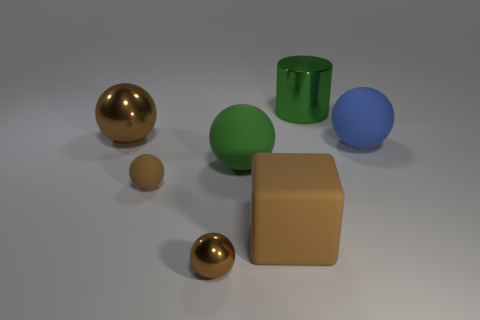What shape is the rubber thing that is the same color as the cylinder?
Your answer should be compact. Sphere. What number of metallic things are behind the metal sphere in front of the blue matte thing?
Your answer should be very brief. 2. How big is the object that is both behind the blue rubber sphere and on the right side of the big green rubber sphere?
Give a very brief answer. Large. Are there any matte blocks of the same size as the brown matte sphere?
Your answer should be compact. No. Is the number of brown matte cubes that are left of the green matte ball greater than the number of small spheres behind the large brown block?
Your answer should be compact. No. Do the big cube and the large brown object that is behind the large blue rubber ball have the same material?
Your answer should be compact. No. There is a big green thing behind the big object on the left side of the brown matte sphere; what number of rubber spheres are to the right of it?
Provide a short and direct response. 1. There is a large blue matte thing; does it have the same shape as the green thing that is in front of the green metal cylinder?
Ensure brevity in your answer.  Yes. The shiny object that is behind the brown rubber cube and right of the large brown ball is what color?
Ensure brevity in your answer.  Green. What is the large ball that is on the left side of the brown metal object that is in front of the brown metal thing behind the blue rubber ball made of?
Offer a terse response. Metal. 